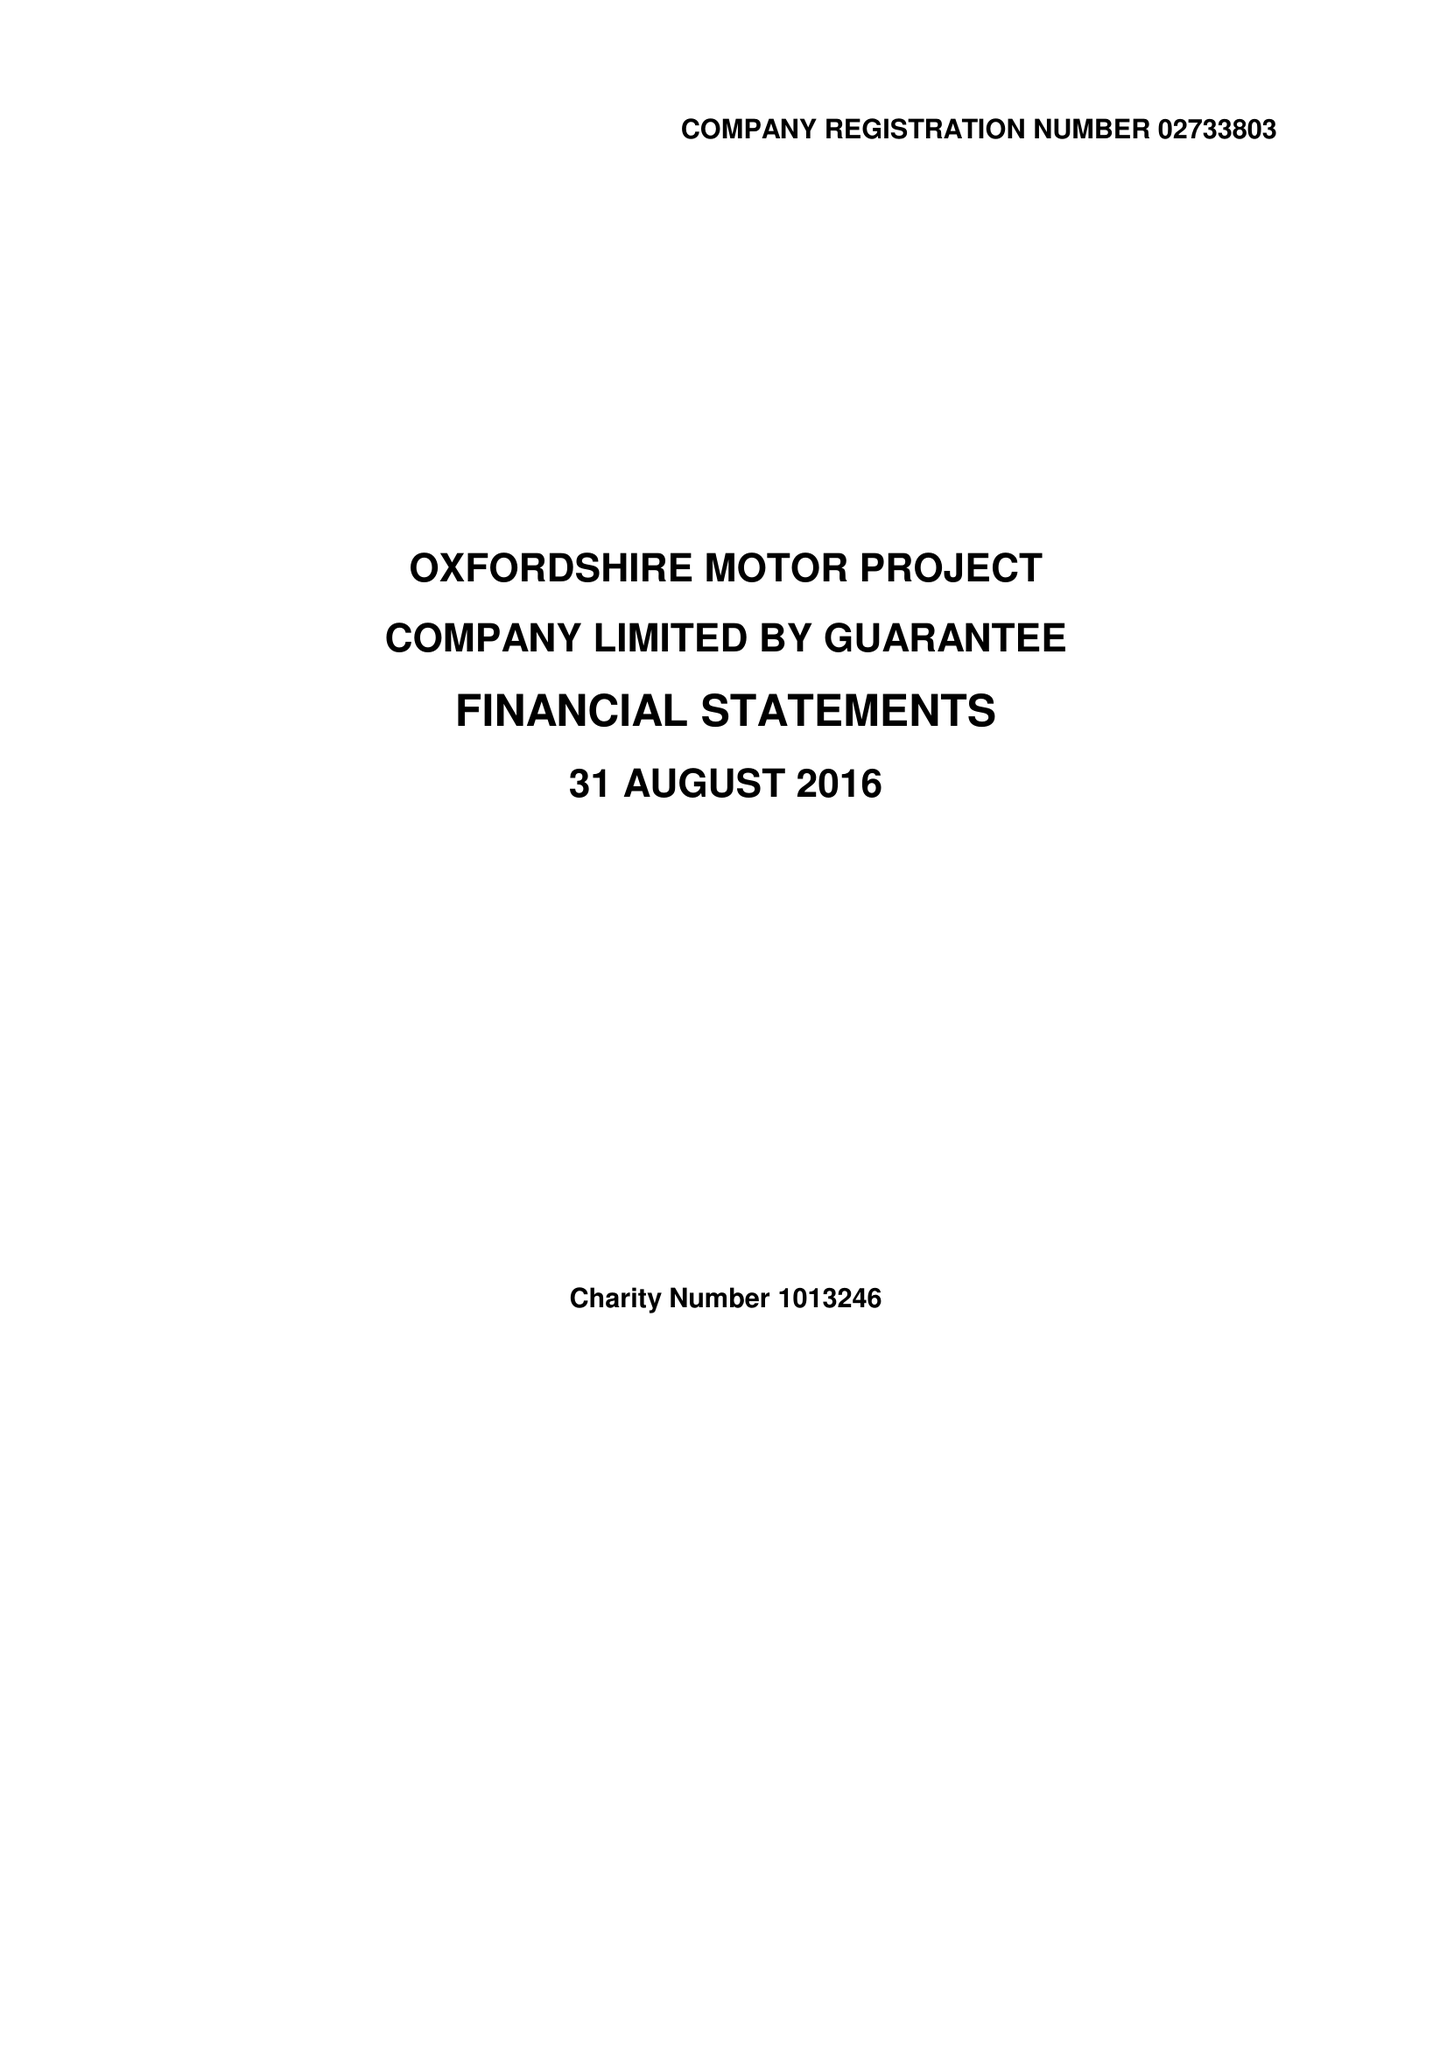What is the value for the address__street_line?
Answer the question using a single word or phrase. WOODSTOCK ROAD 